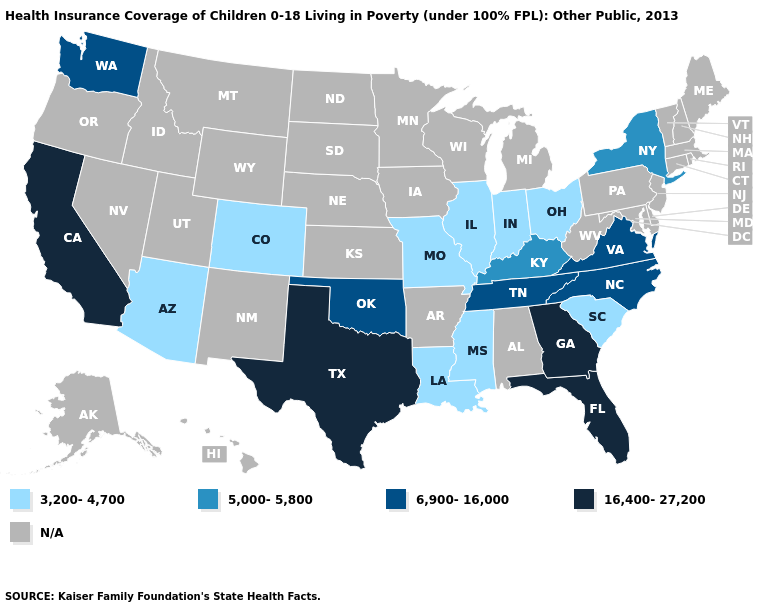Name the states that have a value in the range N/A?
Quick response, please. Alabama, Alaska, Arkansas, Connecticut, Delaware, Hawaii, Idaho, Iowa, Kansas, Maine, Maryland, Massachusetts, Michigan, Minnesota, Montana, Nebraska, Nevada, New Hampshire, New Jersey, New Mexico, North Dakota, Oregon, Pennsylvania, Rhode Island, South Dakota, Utah, Vermont, West Virginia, Wisconsin, Wyoming. Does California have the highest value in the USA?
Short answer required. Yes. Does Mississippi have the lowest value in the South?
Quick response, please. Yes. What is the value of Hawaii?
Write a very short answer. N/A. How many symbols are there in the legend?
Give a very brief answer. 5. What is the lowest value in the USA?
Give a very brief answer. 3,200-4,700. How many symbols are there in the legend?
Short answer required. 5. Name the states that have a value in the range 5,000-5,800?
Quick response, please. Kentucky, New York. Name the states that have a value in the range 6,900-16,000?
Keep it brief. North Carolina, Oklahoma, Tennessee, Virginia, Washington. Among the states that border California , which have the highest value?
Quick response, please. Arizona. Among the states that border Nevada , which have the highest value?
Be succinct. California. Name the states that have a value in the range 3,200-4,700?
Answer briefly. Arizona, Colorado, Illinois, Indiana, Louisiana, Mississippi, Missouri, Ohio, South Carolina. Name the states that have a value in the range N/A?
Answer briefly. Alabama, Alaska, Arkansas, Connecticut, Delaware, Hawaii, Idaho, Iowa, Kansas, Maine, Maryland, Massachusetts, Michigan, Minnesota, Montana, Nebraska, Nevada, New Hampshire, New Jersey, New Mexico, North Dakota, Oregon, Pennsylvania, Rhode Island, South Dakota, Utah, Vermont, West Virginia, Wisconsin, Wyoming. 